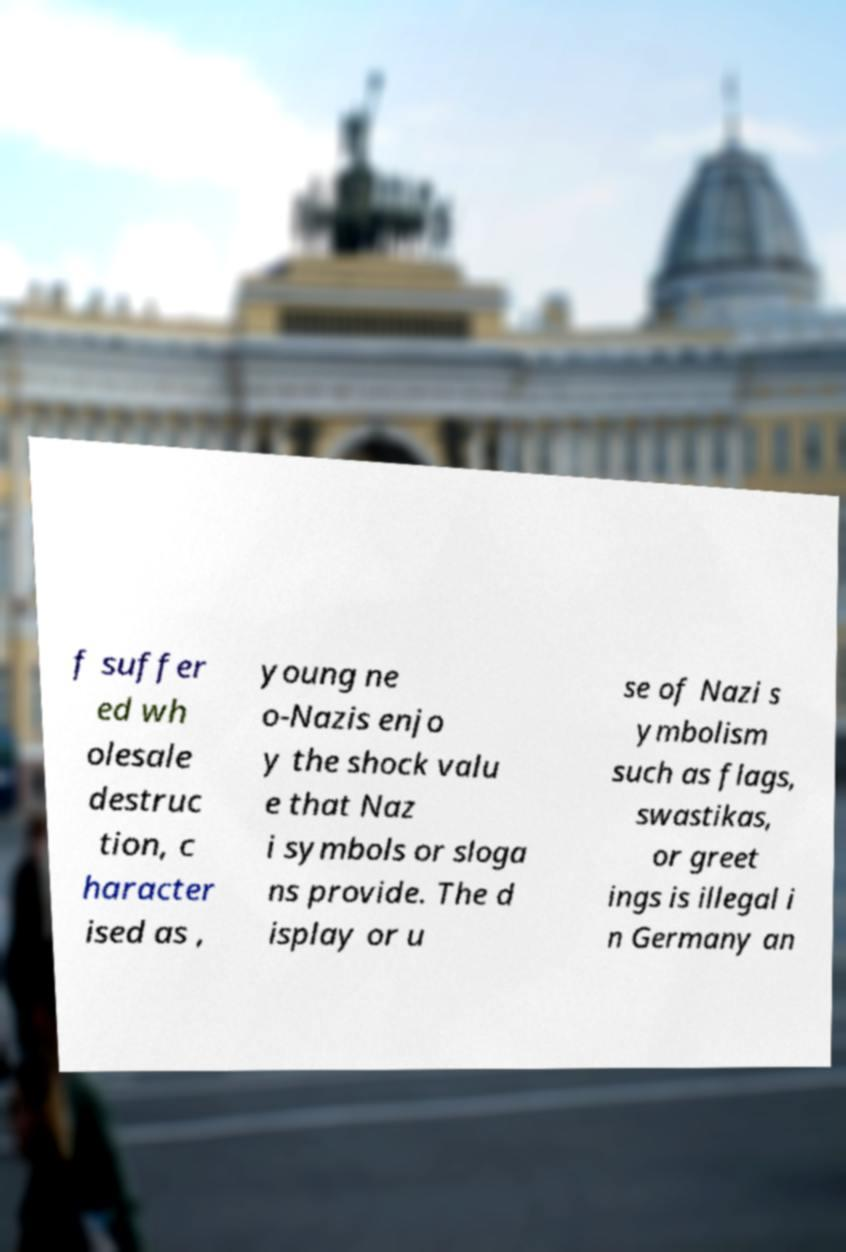Can you read and provide the text displayed in the image?This photo seems to have some interesting text. Can you extract and type it out for me? f suffer ed wh olesale destruc tion, c haracter ised as , young ne o-Nazis enjo y the shock valu e that Naz i symbols or sloga ns provide. The d isplay or u se of Nazi s ymbolism such as flags, swastikas, or greet ings is illegal i n Germany an 